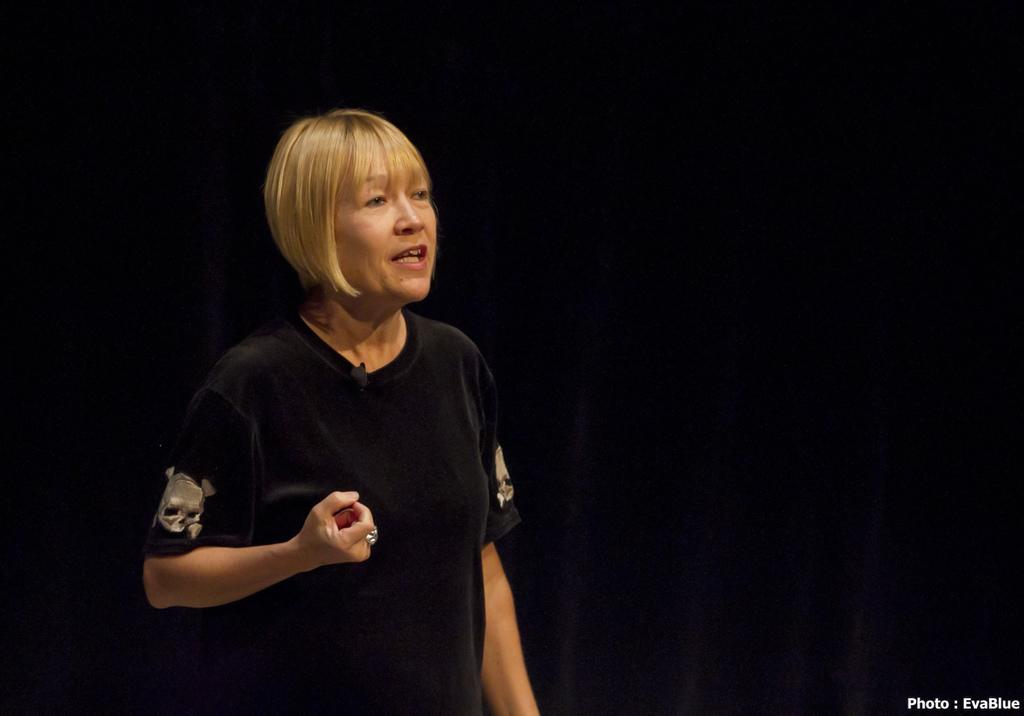What is the main subject of the image? There is a woman standing in the image. What is the woman doing in the image? The woman is speaking. What can be seen behind the woman in the image? There is a dark backdrop in the image. Is there any text or information visible in the image? Yes, there is something written at the right side bottom of the image. Can you see any hearts or wires in the playground depicted in the image? There is no playground depicted in the image, and therefore no hearts or wires can be seen. 